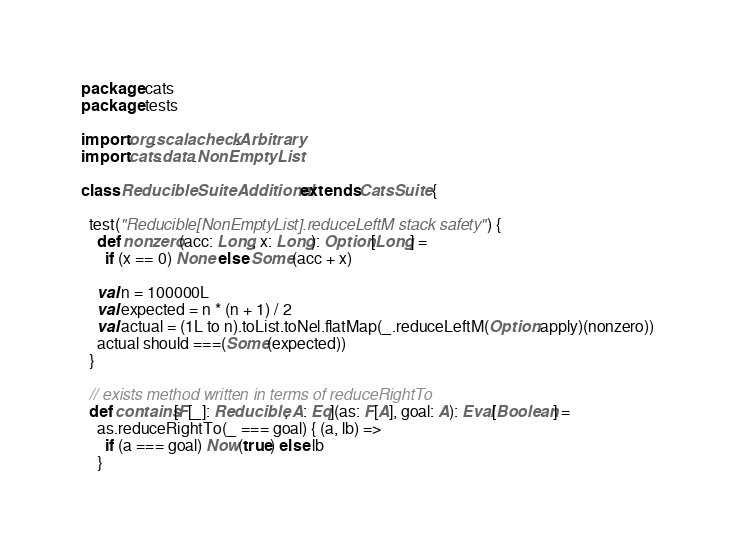Convert code to text. <code><loc_0><loc_0><loc_500><loc_500><_Scala_>package cats
package tests

import org.scalacheck.Arbitrary
import cats.data.NonEmptyList

class ReducibleSuiteAdditional extends CatsSuite {

  test("Reducible[NonEmptyList].reduceLeftM stack safety") {
    def nonzero(acc: Long, x: Long): Option[Long] =
      if (x == 0) None else Some(acc + x)

    val n = 100000L
    val expected = n * (n + 1) / 2
    val actual = (1L to n).toList.toNel.flatMap(_.reduceLeftM(Option.apply)(nonzero))
    actual should ===(Some(expected))
  }

  // exists method written in terms of reduceRightTo
  def contains[F[_]: Reducible, A: Eq](as: F[A], goal: A): Eval[Boolean] =
    as.reduceRightTo(_ === goal) { (a, lb) =>
      if (a === goal) Now(true) else lb
    }
</code> 